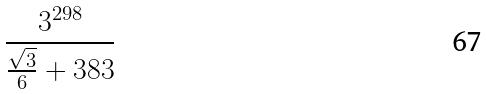Convert formula to latex. <formula><loc_0><loc_0><loc_500><loc_500>\frac { 3 ^ { 2 9 8 } } { \frac { \sqrt { 3 } } { 6 } + 3 8 3 }</formula> 